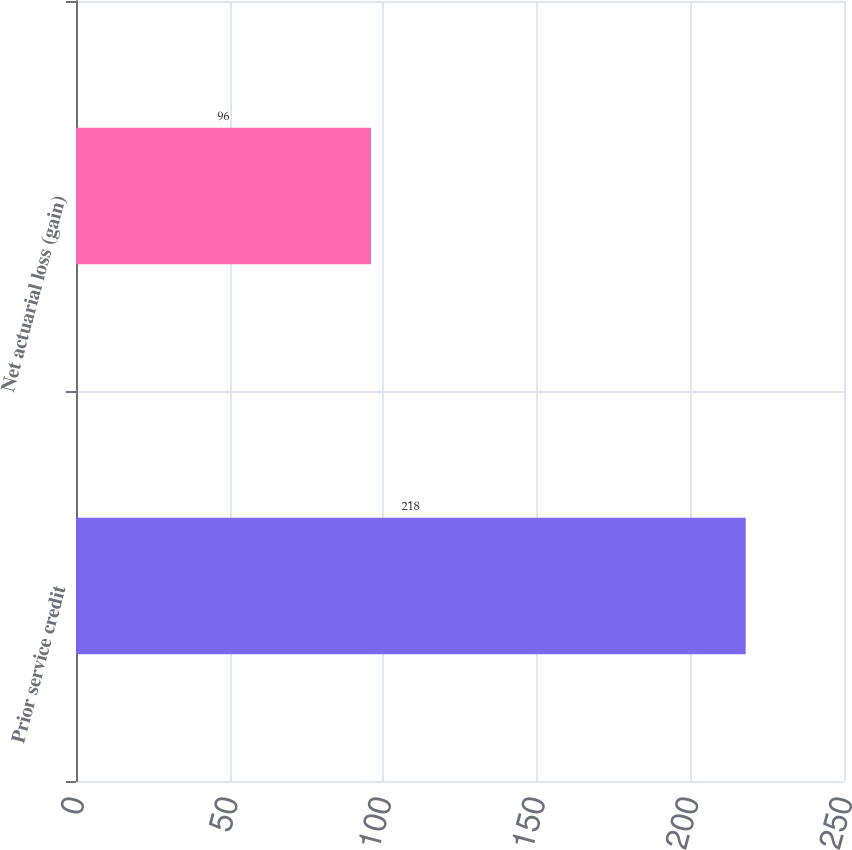Convert chart to OTSL. <chart><loc_0><loc_0><loc_500><loc_500><bar_chart><fcel>Prior service credit<fcel>Net actuarial loss (gain)<nl><fcel>218<fcel>96<nl></chart> 